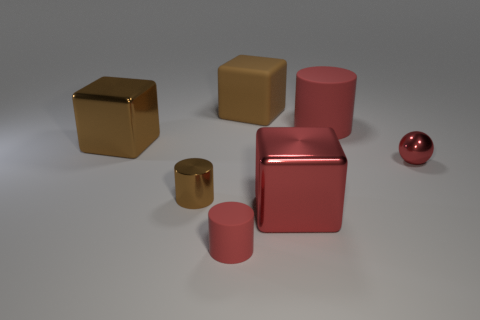There is a big thing that is left of the rubber thing in front of the tiny brown metal object that is behind the tiny rubber cylinder; what is its shape?
Provide a short and direct response. Cube. Do the large red object that is behind the shiny cylinder and the tiny red cylinder that is to the left of the tiny metal ball have the same material?
Keep it short and to the point. Yes. What is the large red cube made of?
Offer a terse response. Metal. What number of tiny objects have the same shape as the big red matte object?
Your answer should be very brief. 2. There is another cylinder that is the same color as the big matte cylinder; what is it made of?
Give a very brief answer. Rubber. Is there anything else that has the same shape as the tiny brown metallic object?
Give a very brief answer. Yes. What color is the matte object that is on the right side of the brown block that is right of the red matte cylinder that is left of the large cylinder?
Provide a short and direct response. Red. What number of small objects are either brown shiny things or brown shiny blocks?
Make the answer very short. 1. Are there the same number of large red matte objects behind the big red rubber cylinder and tiny gray blocks?
Keep it short and to the point. Yes. Are there any metallic things behind the large brown metal block?
Provide a succinct answer. No. 